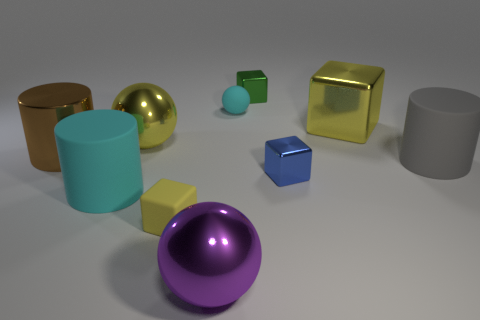How many metal objects are either large brown objects or green things?
Provide a short and direct response. 2. There is another big object that is the same shape as the yellow matte thing; what color is it?
Ensure brevity in your answer.  Yellow. How many things are the same color as the big metal cylinder?
Your response must be concise. 0. Are there any big gray rubber cylinders that are in front of the big rubber cylinder that is on the left side of the blue block?
Make the answer very short. No. What number of large objects are both left of the tiny blue shiny thing and behind the yellow matte cube?
Keep it short and to the point. 3. How many big objects are the same material as the large cyan cylinder?
Ensure brevity in your answer.  1. There is a cylinder that is on the right side of the small rubber thing that is in front of the large block; how big is it?
Keep it short and to the point. Large. Are there any small objects that have the same shape as the big cyan object?
Make the answer very short. No. Do the matte cylinder to the left of the tiny blue block and the metallic block in front of the shiny cylinder have the same size?
Ensure brevity in your answer.  No. Are there fewer brown things in front of the big gray thing than big yellow shiny objects on the left side of the blue thing?
Keep it short and to the point. Yes. 